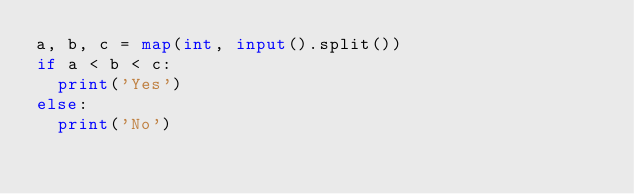Convert code to text. <code><loc_0><loc_0><loc_500><loc_500><_Python_>a, b, c = map(int, input().split())
if a < b < c:
  print('Yes')
else:
  print('No')</code> 